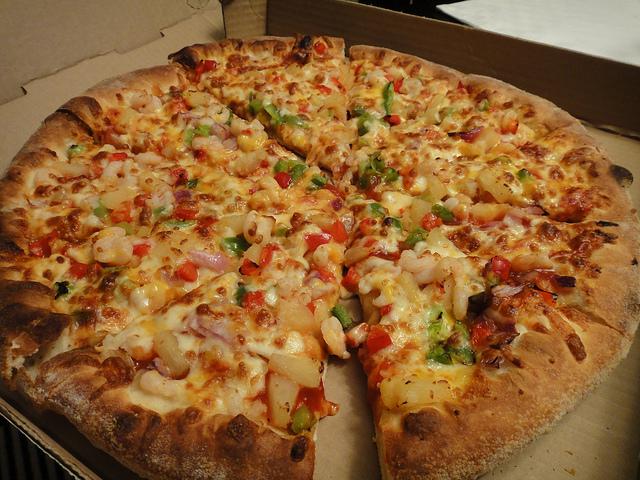Was the pizza cooked on a BBQ grill?
Keep it brief. No. Has the pizza been cut?
Be succinct. Yes. What color sauce is on the pizza?
Keep it brief. Red. What is on the pizza?
Concise answer only. Vegetables. Is the pizza burnt?
Keep it brief. No. Is the correct silverware in the picture needed to eat the pizza?
Quick response, please. Yes. Is there actually a slice missing?
Short answer required. No. 